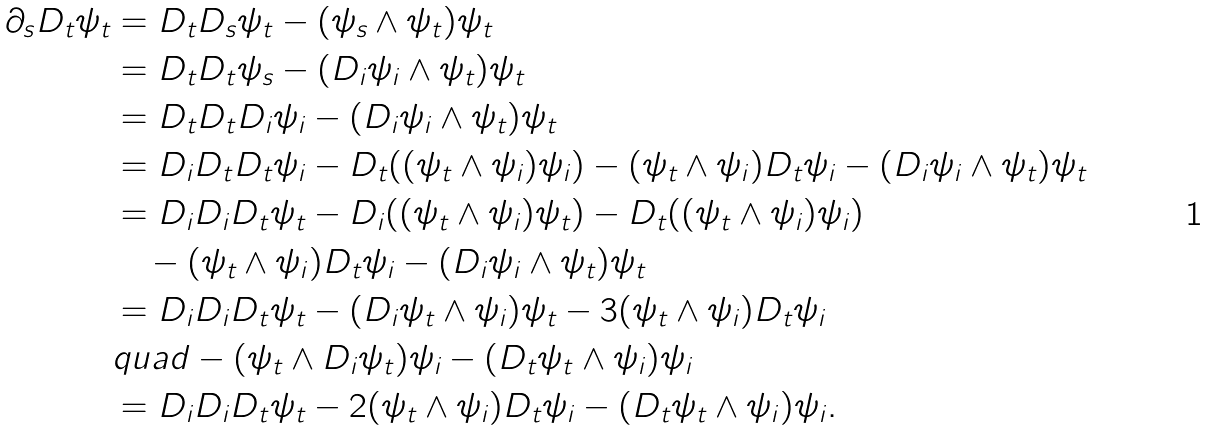<formula> <loc_0><loc_0><loc_500><loc_500>\partial _ { s } D _ { t } \psi _ { t } & = D _ { t } D _ { s } \psi _ { t } - ( \psi _ { s } \wedge \psi _ { t } ) \psi _ { t } \\ & = D _ { t } D _ { t } \psi _ { s } - ( D _ { i } \psi _ { i } \wedge \psi _ { t } ) \psi _ { t } \\ & = D _ { t } D _ { t } D _ { i } \psi _ { i } - ( D _ { i } \psi _ { i } \wedge \psi _ { t } ) \psi _ { t } \\ & = D _ { i } D _ { t } D _ { t } \psi _ { i } - D _ { t } ( ( \psi _ { t } \wedge \psi _ { i } ) \psi _ { i } ) - ( \psi _ { t } \wedge \psi _ { i } ) D _ { t } \psi _ { i } - ( D _ { i } \psi _ { i } \wedge \psi _ { t } ) \psi _ { t } \\ & = D _ { i } D _ { i } D _ { t } \psi _ { t } - D _ { i } ( ( \psi _ { t } \wedge \psi _ { i } ) \psi _ { t } ) - D _ { t } ( ( \psi _ { t } \wedge \psi _ { i } ) \psi _ { i } ) \\ & \quad - ( \psi _ { t } \wedge \psi _ { i } ) D _ { t } \psi _ { i } - ( D _ { i } \psi _ { i } \wedge \psi _ { t } ) \psi _ { t } \\ & = D _ { i } D _ { i } D _ { t } \psi _ { t } - ( D _ { i } \psi _ { t } \wedge \psi _ { i } ) \psi _ { t } - 3 ( \psi _ { t } \wedge \psi _ { i } ) D _ { t } \psi _ { i } \\ & q u a d - ( \psi _ { t } \wedge D _ { i } \psi _ { t } ) \psi _ { i } - ( D _ { t } \psi _ { t } \wedge \psi _ { i } ) \psi _ { i } \\ & = D _ { i } D _ { i } D _ { t } \psi _ { t } - 2 ( \psi _ { t } \wedge \psi _ { i } ) D _ { t } \psi _ { i } - ( D _ { t } \psi _ { t } \wedge \psi _ { i } ) \psi _ { i } .</formula> 